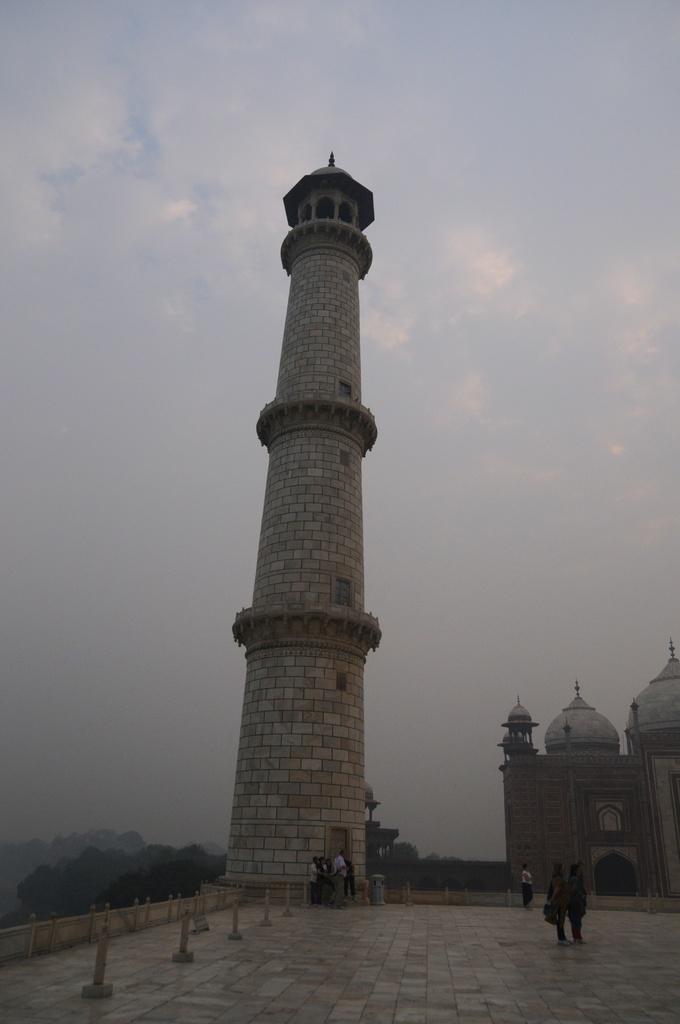Please provide a concise description of this image. On the right of the image we can see a monument. In the center there is a minar. At the bottom there are people. In the background there are trees and sky. 